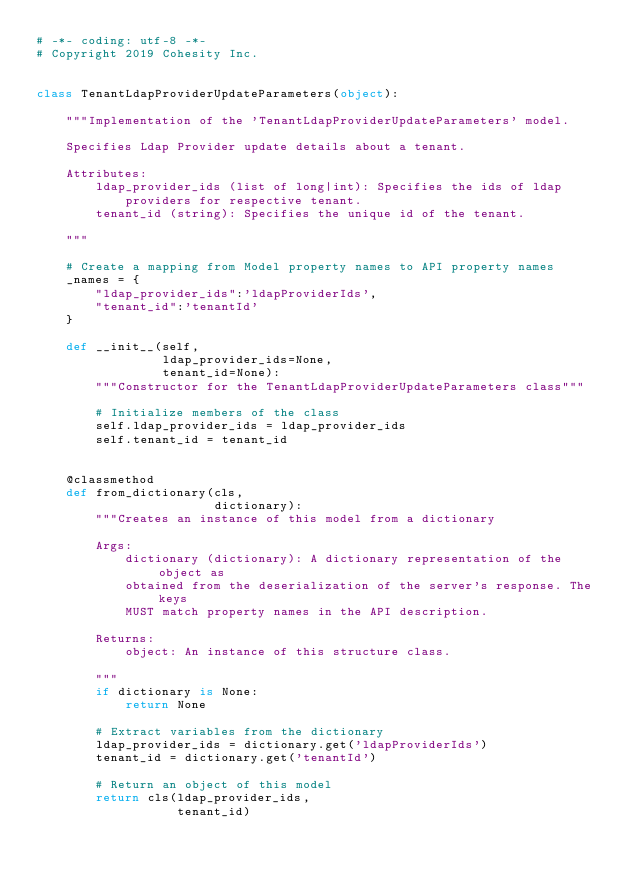Convert code to text. <code><loc_0><loc_0><loc_500><loc_500><_Python_># -*- coding: utf-8 -*-
# Copyright 2019 Cohesity Inc.


class TenantLdapProviderUpdateParameters(object):

    """Implementation of the 'TenantLdapProviderUpdateParameters' model.

    Specifies Ldap Provider update details about a tenant.

    Attributes:
        ldap_provider_ids (list of long|int): Specifies the ids of ldap
            providers for respective tenant.
        tenant_id (string): Specifies the unique id of the tenant.

    """

    # Create a mapping from Model property names to API property names
    _names = {
        "ldap_provider_ids":'ldapProviderIds',
        "tenant_id":'tenantId'
    }

    def __init__(self,
                 ldap_provider_ids=None,
                 tenant_id=None):
        """Constructor for the TenantLdapProviderUpdateParameters class"""

        # Initialize members of the class
        self.ldap_provider_ids = ldap_provider_ids
        self.tenant_id = tenant_id


    @classmethod
    def from_dictionary(cls,
                        dictionary):
        """Creates an instance of this model from a dictionary

        Args:
            dictionary (dictionary): A dictionary representation of the object as
            obtained from the deserialization of the server's response. The keys
            MUST match property names in the API description.

        Returns:
            object: An instance of this structure class.

        """
        if dictionary is None:
            return None

        # Extract variables from the dictionary
        ldap_provider_ids = dictionary.get('ldapProviderIds')
        tenant_id = dictionary.get('tenantId')

        # Return an object of this model
        return cls(ldap_provider_ids,
                   tenant_id)


</code> 